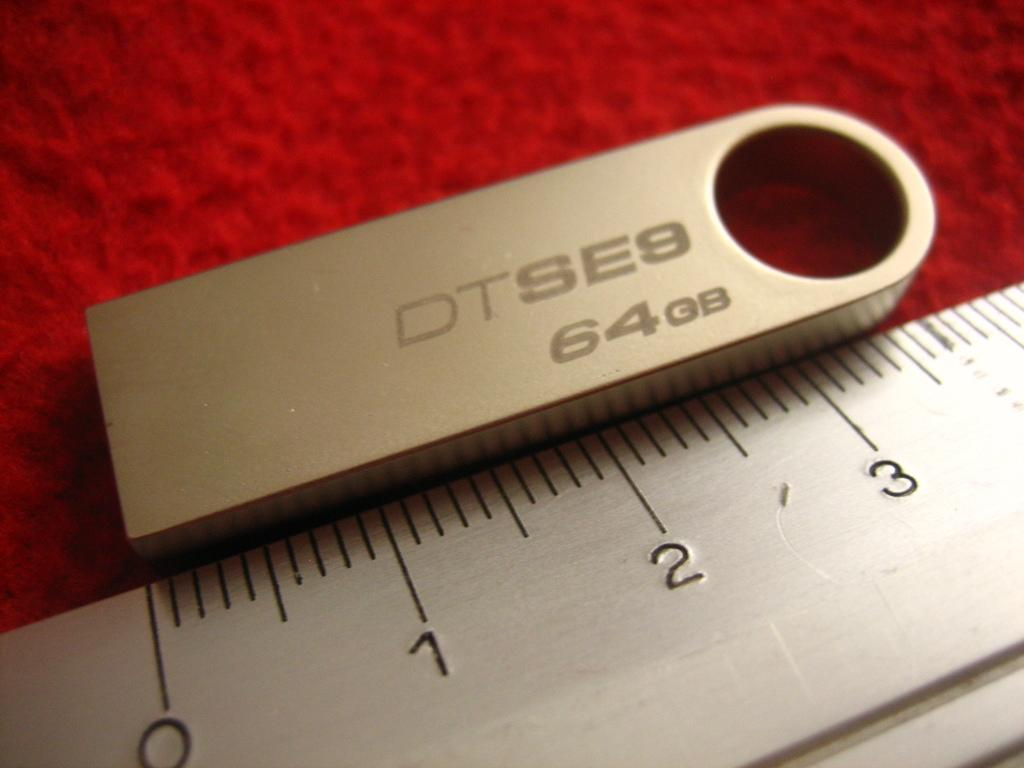<image>
Render a clear and concise summary of the photo. A very small 64 GB memory card that is just over 3" long. 